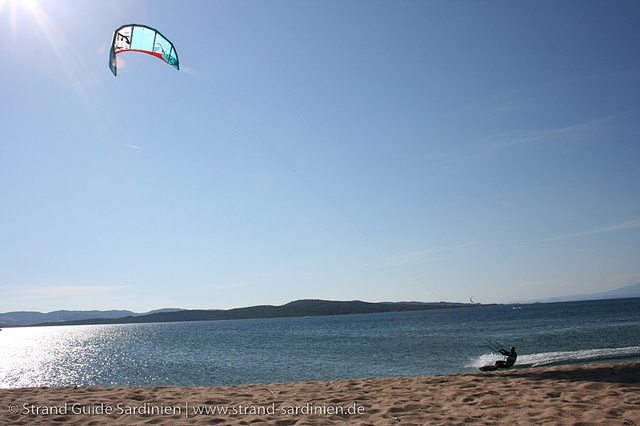Describe the objects in this image and their specific colors. I can see kite in white, lightblue, blue, and black tones, people in white, black, gray, purple, and maroon tones, surfboard in white, black, and gray tones, and boat in white, gray, and darkblue tones in this image. 